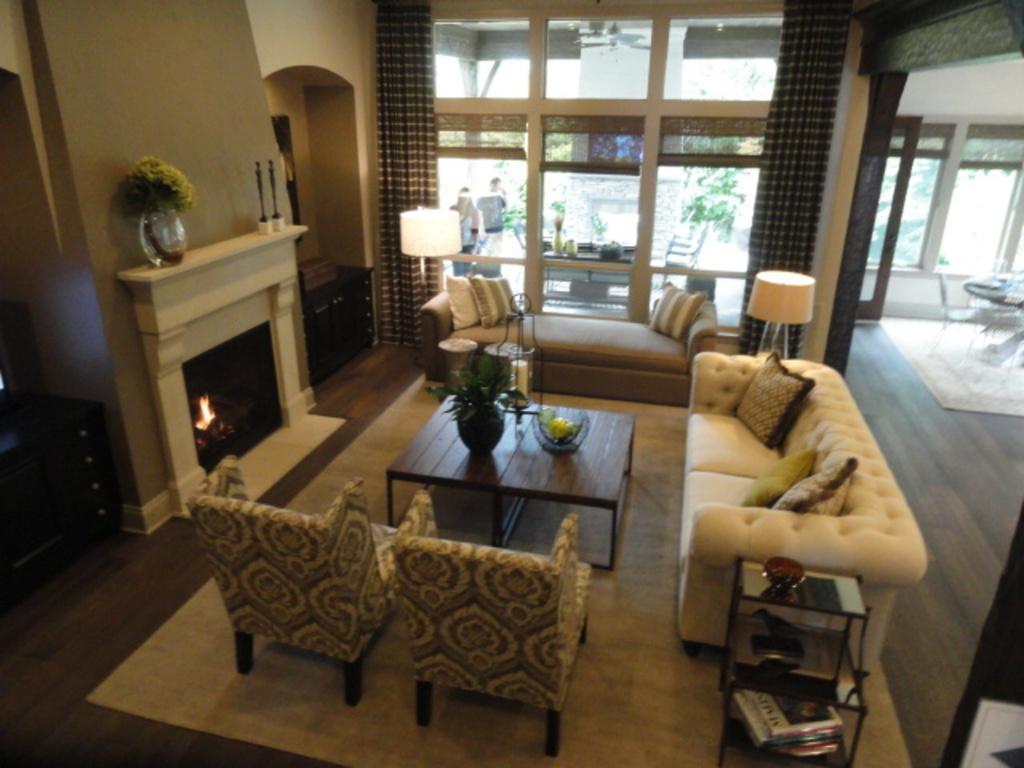Please provide a concise description of this image. This is completely an indoor picture. In this picture we can see sofas and chairs with cushions. We can see a table and on the table we can see a houseplant. Here in this rock we can see magazines. These are windows and curtains. through window glass we can see two persons , a table and a flower vase. This is a floor, floor carpet. 